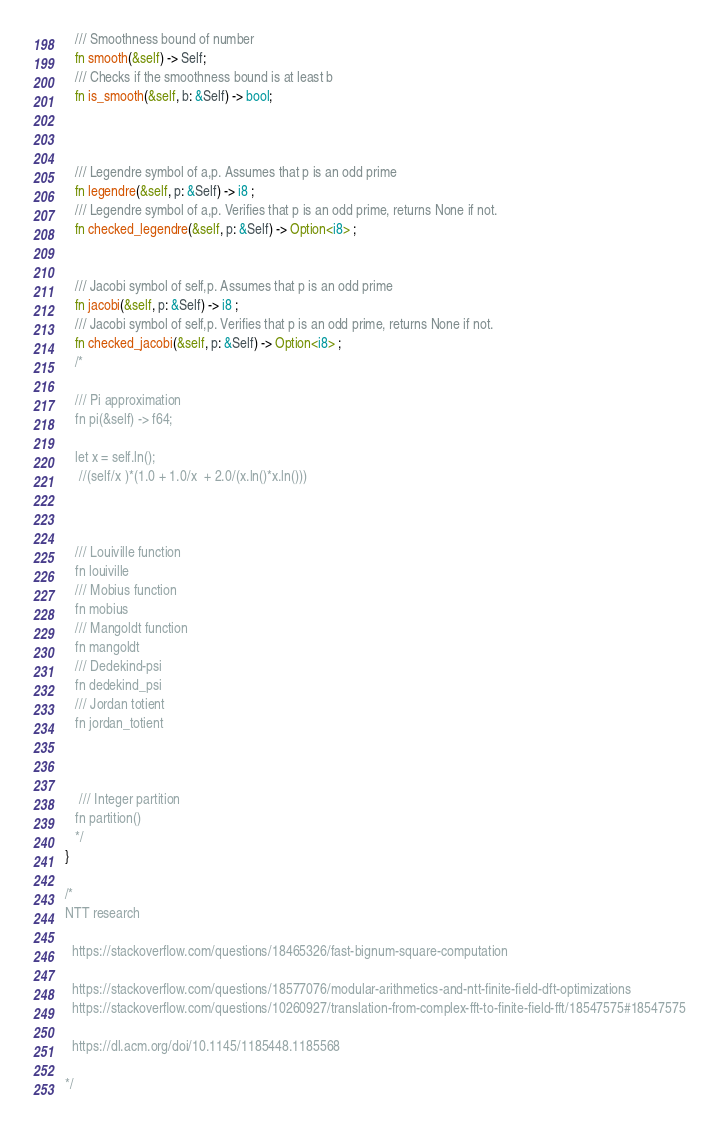Convert code to text. <code><loc_0><loc_0><loc_500><loc_500><_Rust_>   /// Smoothness bound of number
   fn smooth(&self) -> Self;
   /// Checks if the smoothness bound is at least b
   fn is_smooth(&self, b: &Self) -> bool;
   
   
   
   /// Legendre symbol of a,p. Assumes that p is an odd prime
   fn legendre(&self, p: &Self) -> i8 ;   
   /// Legendre symbol of a,p. Verifies that p is an odd prime, returns None if not. 
   fn checked_legendre(&self, p: &Self) -> Option<i8> ;
   
   
   /// Jacobi symbol of self,p. Assumes that p is an odd prime
   fn jacobi(&self, p: &Self) -> i8 ;  
   /// Jacobi symbol of self,p. Verifies that p is an odd prime, returns None if not. 
   fn checked_jacobi(&self, p: &Self) -> Option<i8> ;
   /*
   
   /// Pi approximation
   fn pi(&self) -> f64;
   
   let x = self.ln();
    //(self/x )*(1.0 + 1.0/x  + 2.0/(x.ln()*x.ln()))
       
   
   
   /// Louiville function
   fn louiville
   /// Mobius function
   fn mobius
   /// Mangoldt function 
   fn mangoldt
   /// Dedekind-psi
   fn dedekind_psi
   /// Jordan totient
   fn jordan_totient
   
   
   
    /// Integer partition
   fn partition()
   */
}

/*
NTT research 

  https://stackoverflow.com/questions/18465326/fast-bignum-square-computation
  
  https://stackoverflow.com/questions/18577076/modular-arithmetics-and-ntt-finite-field-dft-optimizations
  https://stackoverflow.com/questions/10260927/translation-from-complex-fft-to-finite-field-fft/18547575#18547575
  
  https://dl.acm.org/doi/10.1145/1185448.1185568

*/

</code> 